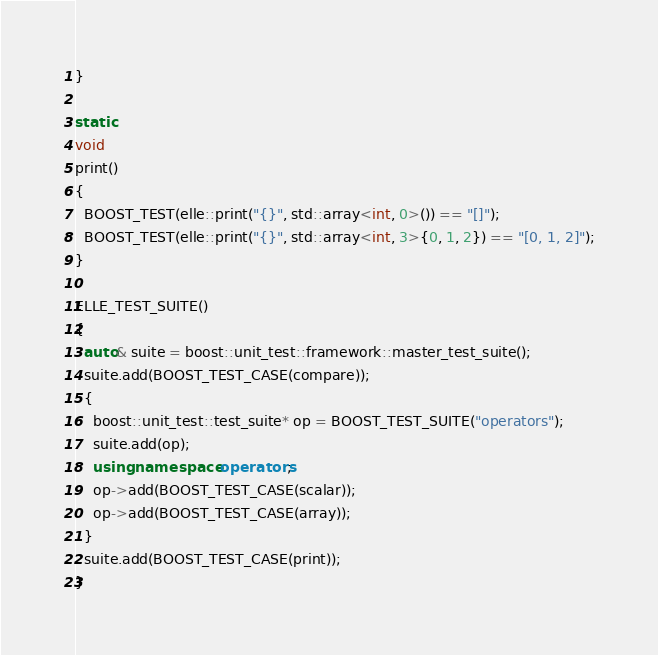<code> <loc_0><loc_0><loc_500><loc_500><_C++_>}

static
void
print()
{
  BOOST_TEST(elle::print("{}", std::array<int, 0>()) == "[]");
  BOOST_TEST(elle::print("{}", std::array<int, 3>{0, 1, 2}) == "[0, 1, 2]");
}

ELLE_TEST_SUITE()
{
  auto& suite = boost::unit_test::framework::master_test_suite();
  suite.add(BOOST_TEST_CASE(compare));
  {
    boost::unit_test::test_suite* op = BOOST_TEST_SUITE("operators");
    suite.add(op);
    using namespace operators;
    op->add(BOOST_TEST_CASE(scalar));
    op->add(BOOST_TEST_CASE(array));
  }
  suite.add(BOOST_TEST_CASE(print));
}
</code> 